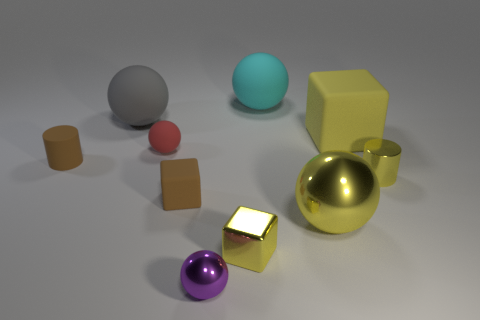How many metallic things are red things or big cylinders?
Give a very brief answer. 0. Do the small metallic cylinder and the big metal thing have the same color?
Make the answer very short. Yes. What number of large yellow things are behind the tiny red rubber sphere?
Your response must be concise. 1. What number of large spheres are both behind the small red rubber thing and right of the large cyan thing?
Provide a succinct answer. 0. What shape is the big yellow object that is made of the same material as the tiny purple object?
Ensure brevity in your answer.  Sphere. Does the brown matte thing that is to the right of the gray matte thing have the same size as the matte object behind the big gray ball?
Make the answer very short. No. What color is the rubber block behind the shiny cylinder?
Provide a short and direct response. Yellow. What material is the cylinder left of the large cyan rubber sphere behind the small purple ball?
Provide a short and direct response. Rubber. The cyan rubber thing has what shape?
Provide a succinct answer. Sphere. There is a red object that is the same shape as the purple object; what material is it?
Your response must be concise. Rubber. 